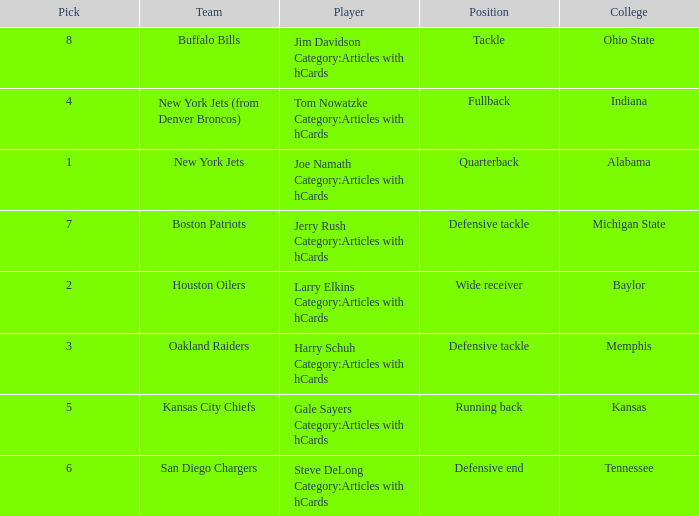Can you give me this table as a dict? {'header': ['Pick', 'Team', 'Player', 'Position', 'College'], 'rows': [['8', 'Buffalo Bills', 'Jim Davidson Category:Articles with hCards', 'Tackle', 'Ohio State'], ['4', 'New York Jets (from Denver Broncos)', 'Tom Nowatzke Category:Articles with hCards', 'Fullback', 'Indiana'], ['1', 'New York Jets', 'Joe Namath Category:Articles with hCards', 'Quarterback', 'Alabama'], ['7', 'Boston Patriots', 'Jerry Rush Category:Articles with hCards', 'Defensive tackle', 'Michigan State'], ['2', 'Houston Oilers', 'Larry Elkins Category:Articles with hCards', 'Wide receiver', 'Baylor'], ['3', 'Oakland Raiders', 'Harry Schuh Category:Articles with hCards', 'Defensive tackle', 'Memphis'], ['5', 'Kansas City Chiefs', 'Gale Sayers Category:Articles with hCards', 'Running back', 'Kansas'], ['6', 'San Diego Chargers', 'Steve DeLong Category:Articles with hCards', 'Defensive end', 'Tennessee']]} What team has a position of running back and picked after 2? Kansas City Chiefs. 